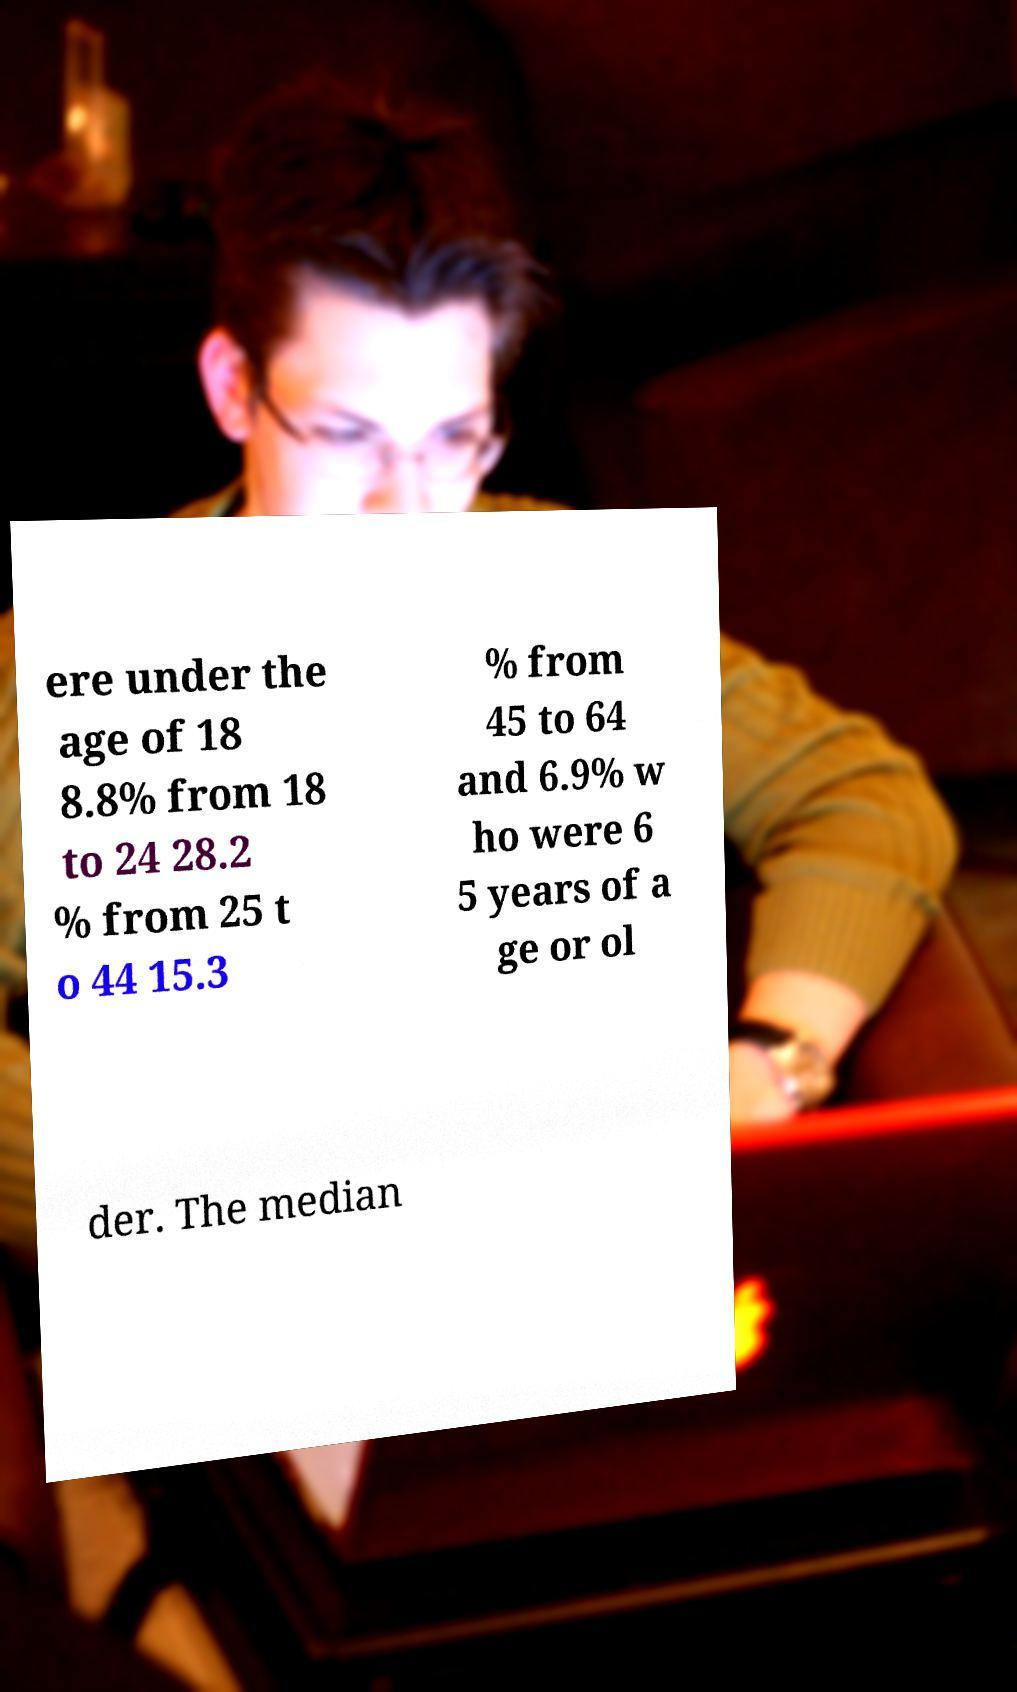Could you extract and type out the text from this image? ere under the age of 18 8.8% from 18 to 24 28.2 % from 25 t o 44 15.3 % from 45 to 64 and 6.9% w ho were 6 5 years of a ge or ol der. The median 